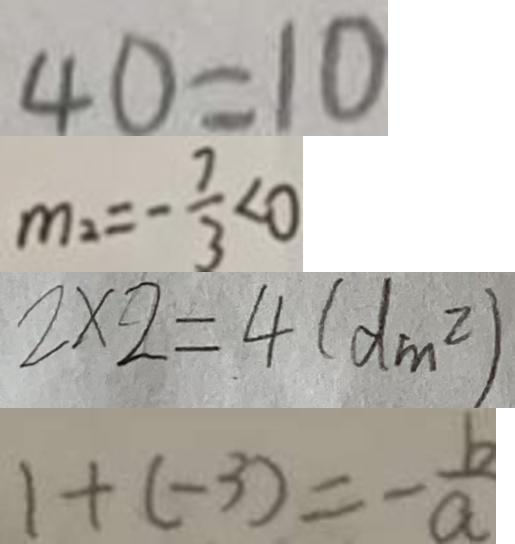<formula> <loc_0><loc_0><loc_500><loc_500>4 0 = 1 0 
 m _ { 2 } = - \frac { 7 } { 3 } < 0 
 2 \times 2 = 4 ( d m ^ { 2 } ) 
 1 + ( - 3 ) = - \frac { b } { a }</formula> 